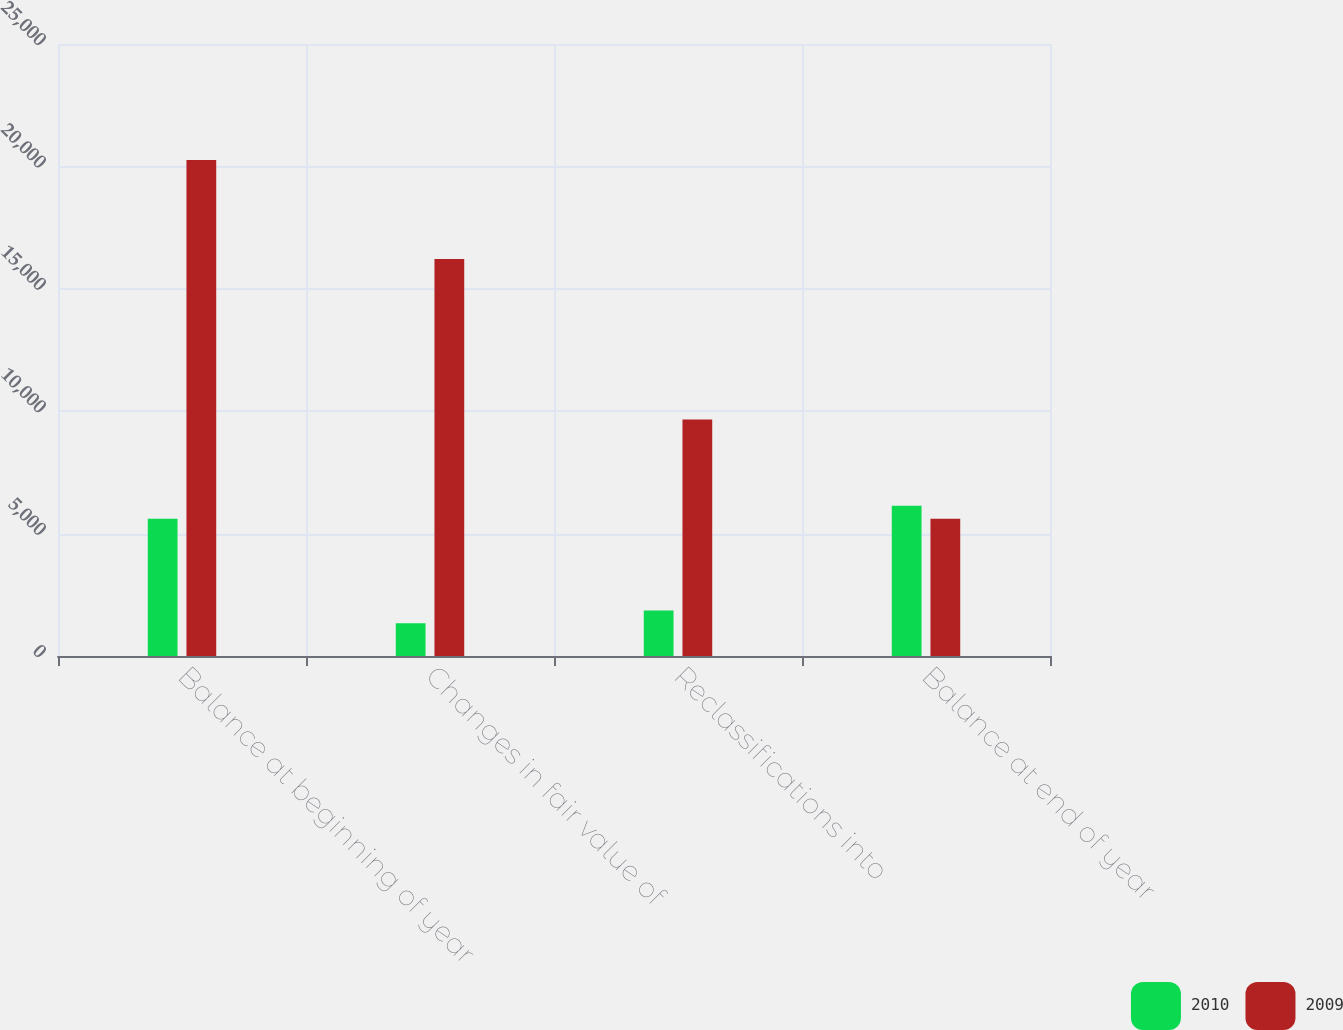Convert chart to OTSL. <chart><loc_0><loc_0><loc_500><loc_500><stacked_bar_chart><ecel><fcel>Balance at beginning of year<fcel>Changes in fair value of<fcel>Reclassifications into<fcel>Balance at end of year<nl><fcel>2010<fcel>5609<fcel>1339<fcel>1863<fcel>6133<nl><fcel>2009<fcel>20263<fcel>16215<fcel>9657<fcel>5609<nl></chart> 